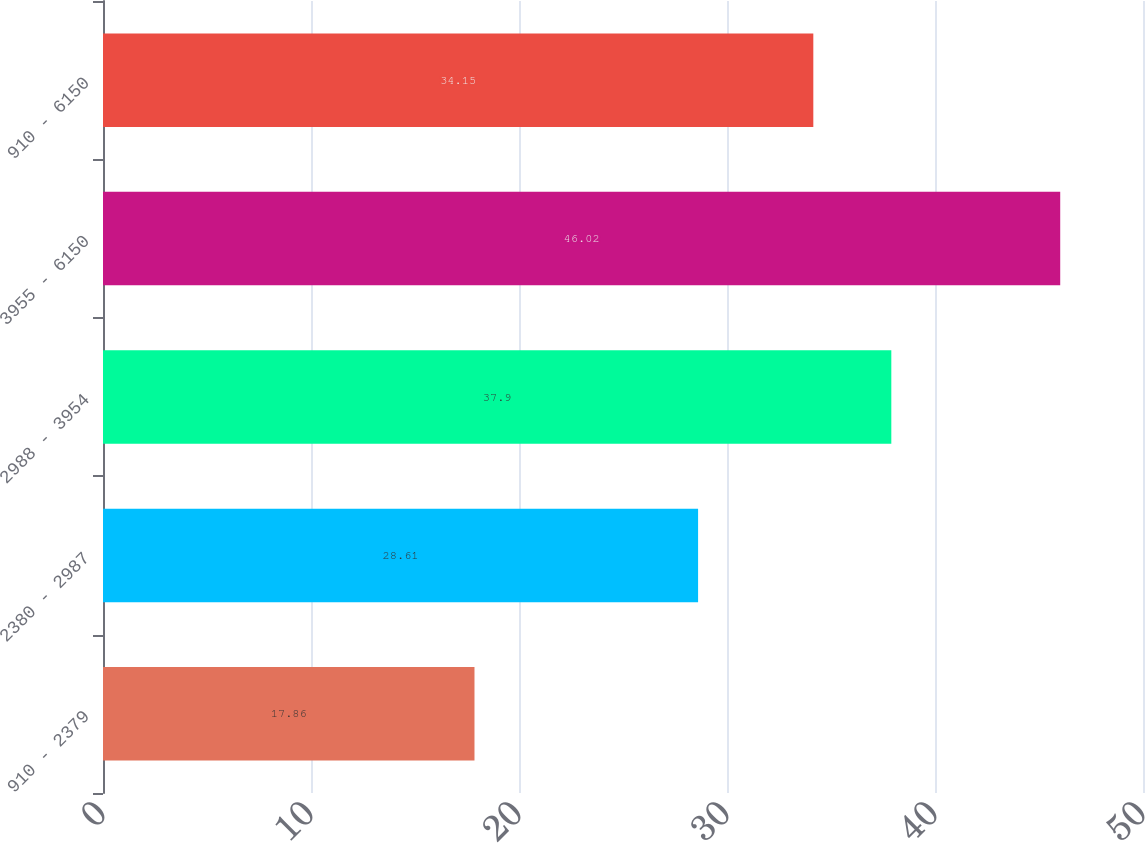Convert chart to OTSL. <chart><loc_0><loc_0><loc_500><loc_500><bar_chart><fcel>910 - 2379<fcel>2380 - 2987<fcel>2988 - 3954<fcel>3955 - 6150<fcel>910 - 6150<nl><fcel>17.86<fcel>28.61<fcel>37.9<fcel>46.02<fcel>34.15<nl></chart> 